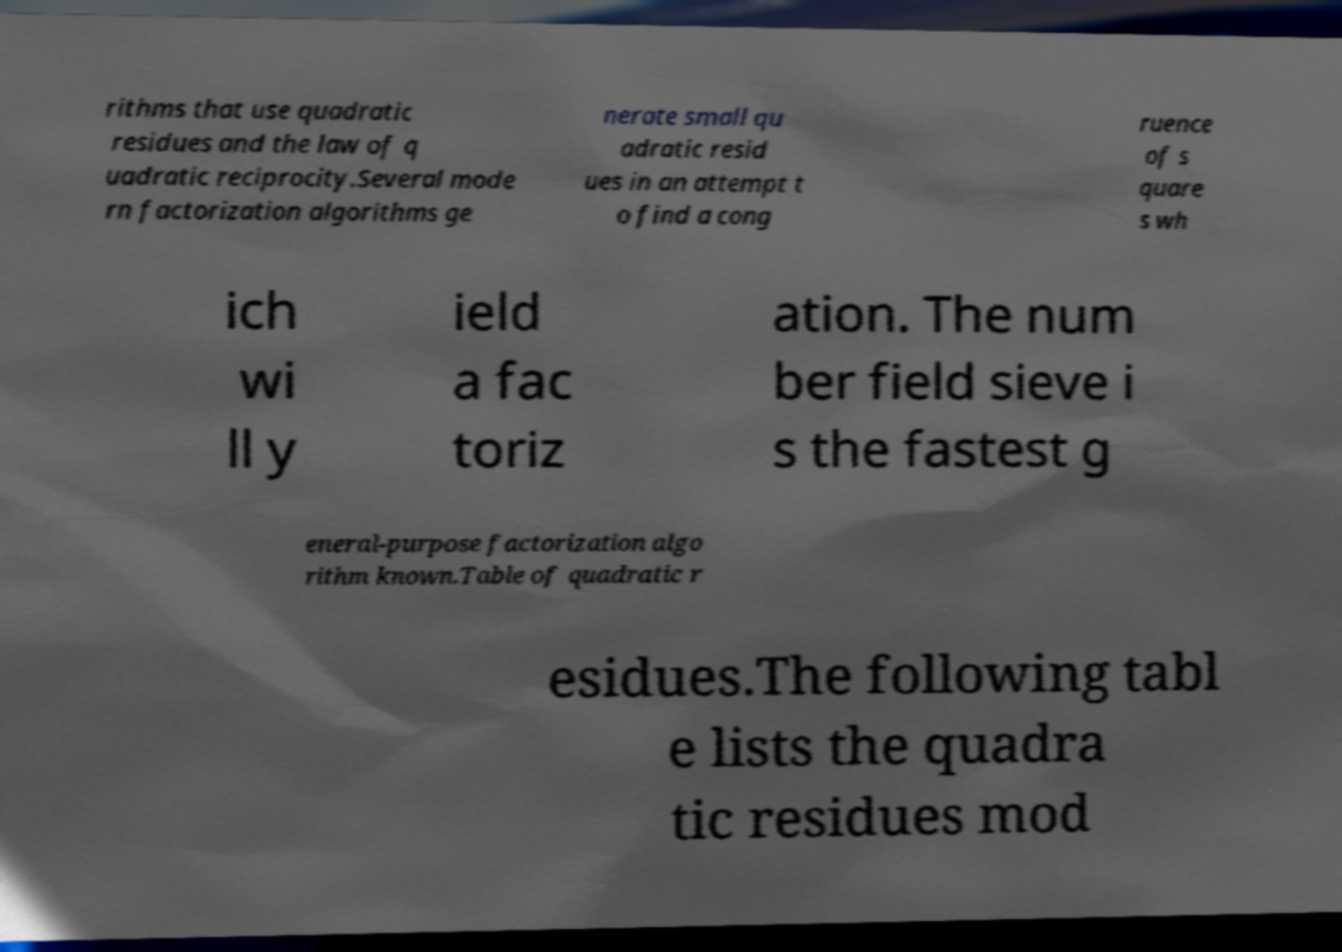Can you read and provide the text displayed in the image?This photo seems to have some interesting text. Can you extract and type it out for me? rithms that use quadratic residues and the law of q uadratic reciprocity.Several mode rn factorization algorithms ge nerate small qu adratic resid ues in an attempt t o find a cong ruence of s quare s wh ich wi ll y ield a fac toriz ation. The num ber field sieve i s the fastest g eneral-purpose factorization algo rithm known.Table of quadratic r esidues.The following tabl e lists the quadra tic residues mod 